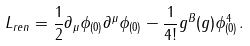<formula> <loc_0><loc_0><loc_500><loc_500>L _ { r e n } = \frac { 1 } { 2 } \partial _ { \mu } \phi _ { ( 0 ) } \partial ^ { \mu } \phi _ { ( 0 ) } - \frac { 1 } { 4 ! } g ^ { B } ( g ) \phi ^ { 4 } _ { ( 0 ) } .</formula> 